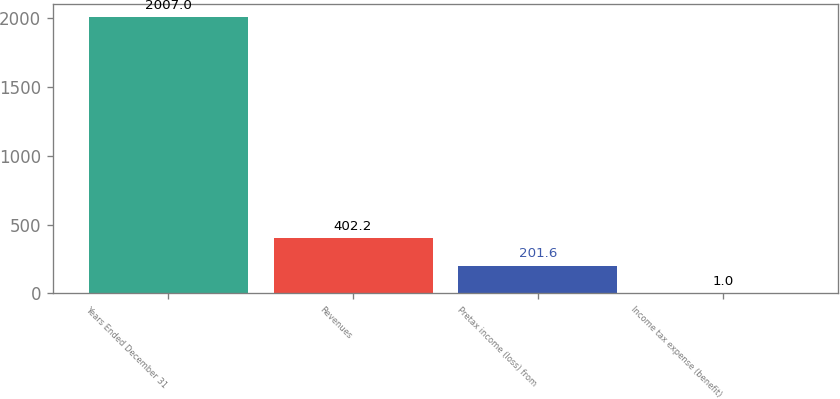Convert chart to OTSL. <chart><loc_0><loc_0><loc_500><loc_500><bar_chart><fcel>Years Ended December 31<fcel>Revenues<fcel>Pretax income (loss) from<fcel>Income tax expense (benefit)<nl><fcel>2007<fcel>402.2<fcel>201.6<fcel>1<nl></chart> 